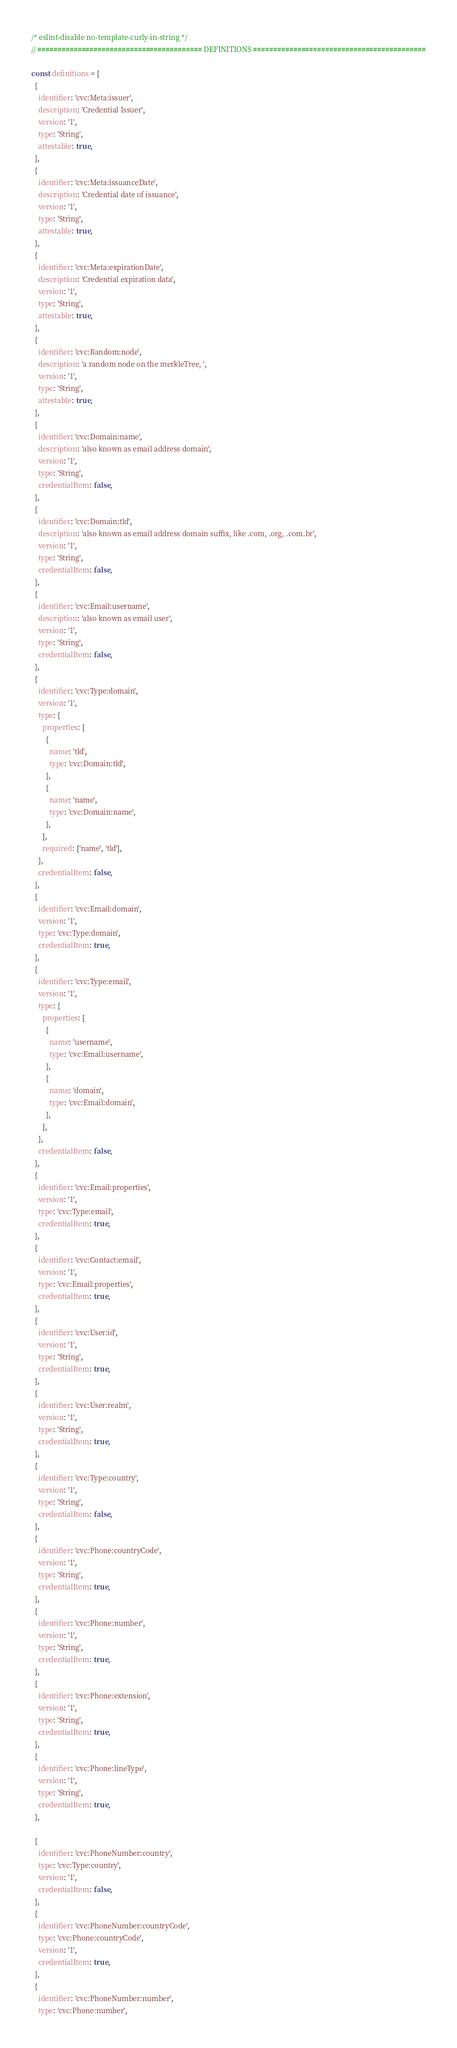Convert code to text. <code><loc_0><loc_0><loc_500><loc_500><_JavaScript_>/* eslint-disable no-template-curly-in-string */
// ######################################### DEFINITIONS ###########################################

const definitions = [
  {
    identifier: 'cvc:Meta:issuer',
    description: 'Credential Issuer',
    version: '1',
    type: 'String',
    attestable: true,
  },
  {
    identifier: 'cvc:Meta:issuanceDate',
    description: 'Credential date of issuance',
    version: '1',
    type: 'String',
    attestable: true,
  },
  {
    identifier: 'cvc:Meta:expirationDate',
    description: 'Credential expiration data',
    version: '1',
    type: 'String',
    attestable: true,
  },
  {
    identifier: 'cvc:Random:node',
    description: 'a random node on the merkleTree, ',
    version: '1',
    type: 'String',
    attestable: true,
  },
  {
    identifier: 'cvc:Domain:name',
    description: 'also known as email address domain',
    version: '1',
    type: 'String',
    credentialItem: false,
  },
  {
    identifier: 'cvc:Domain:tld',
    description: 'also known as email address domain suffix, like .com, .org, .com.br',
    version: '1',
    type: 'String',
    credentialItem: false,
  },
  {
    identifier: 'cvc:Email:username',
    description: 'also known as email user',
    version: '1',
    type: 'String',
    credentialItem: false,
  },
  {
    identifier: 'cvc:Type:domain',
    version: '1',
    type: {
      properties: [
        {
          name: 'tld',
          type: 'cvc:Domain:tld',
        },
        {
          name: 'name',
          type: 'cvc:Domain:name',
        },
      ],
      required: ['name', 'tld'],
    },
    credentialItem: false,
  },
  {
    identifier: 'cvc:Email:domain',
    version: '1',
    type: 'cvc:Type:domain',
    credentialItem: true,
  },
  {
    identifier: 'cvc:Type:email',
    version: '1',
    type: {
      properties: [
        {
          name: 'username',
          type: 'cvc:Email:username',
        },
        {
          name: 'domain',
          type: 'cvc:Email:domain',
        },
      ],
    },
    credentialItem: false,
  },
  {
    identifier: 'cvc:Email:properties',
    version: '1',
    type: 'cvc:Type:email',
    credentialItem: true,
  },
  {
    identifier: 'cvc:Contact:email',
    version: '1',
    type: 'cvc:Email:properties',
    credentialItem: true,
  },
  {
    identifier: 'cvc:User:id',
    version: '1',
    type: 'String',
    credentialItem: true,
  },
  {
    identifier: 'cvc:User:realm',
    version: '1',
    type: 'String',
    credentialItem: true,
  },
  {
    identifier: 'cvc:Type:country',
    version: '1',
    type: 'String',
    credentialItem: false,
  },
  {
    identifier: 'cvc:Phone:countryCode',
    version: '1',
    type: 'String',
    credentialItem: true,
  },
  {
    identifier: 'cvc:Phone:number',
    version: '1',
    type: 'String',
    credentialItem: true,
  },
  {
    identifier: 'cvc:Phone:extension',
    version: '1',
    type: 'String',
    credentialItem: true,
  },
  {
    identifier: 'cvc:Phone:lineType',
    version: '1',
    type: 'String',
    credentialItem: true,
  },

  {
    identifier: 'cvc:PhoneNumber:country',
    type: 'cvc:Type:country',
    version: '1',
    credentialItem: false,
  },
  {
    identifier: 'cvc:PhoneNumber:countryCode',
    type: 'cvc:Phone:countryCode',
    version: '1',
    credentialItem: true,
  },
  {
    identifier: 'cvc:PhoneNumber:number',
    type: 'cvc:Phone:number',</code> 